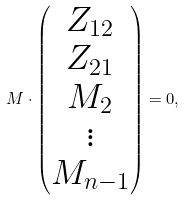Convert formula to latex. <formula><loc_0><loc_0><loc_500><loc_500>M \cdot \begin{pmatrix} Z _ { 1 2 } \\ Z _ { 2 1 } \\ M _ { 2 } \\ \vdots \\ M _ { n - 1 } \end{pmatrix} = 0 ,</formula> 